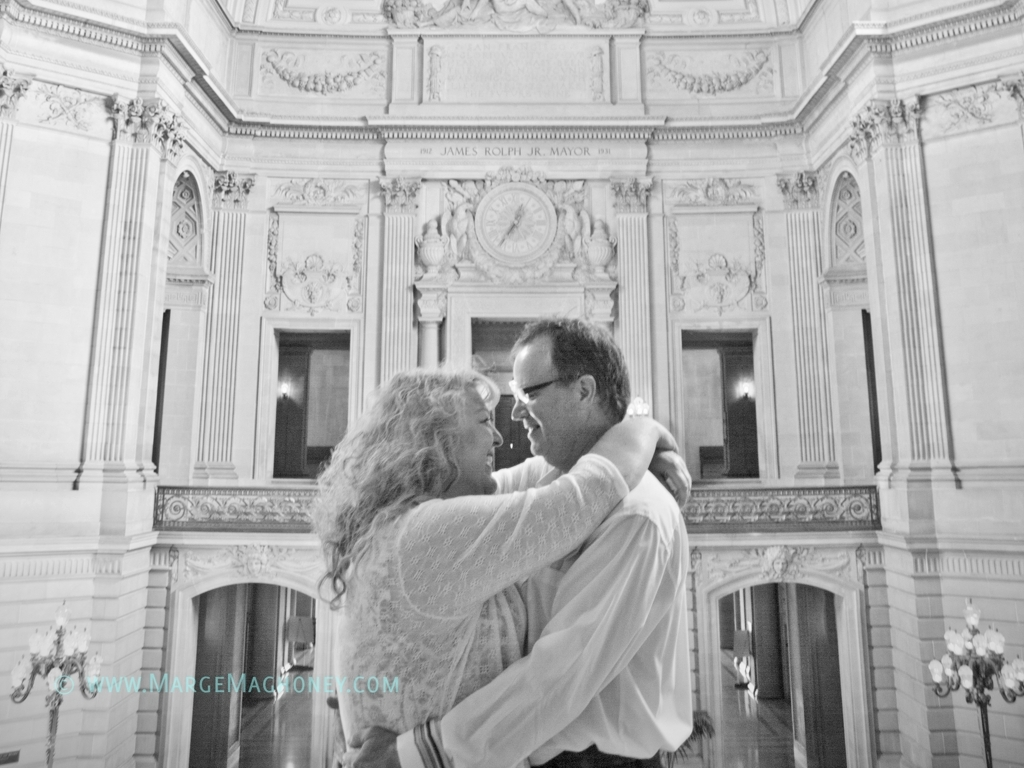What might be the occasion for this photograph? Given the formal attire of the individuals and the grandiose setting, this photograph is likely taken during a significant event such as a wedding or a formal celebration. Their attire, a lace dress and a neat suit, along with the intimate pose, suggest a personal and festive occasion, possibly marking a milestone in their lives. 